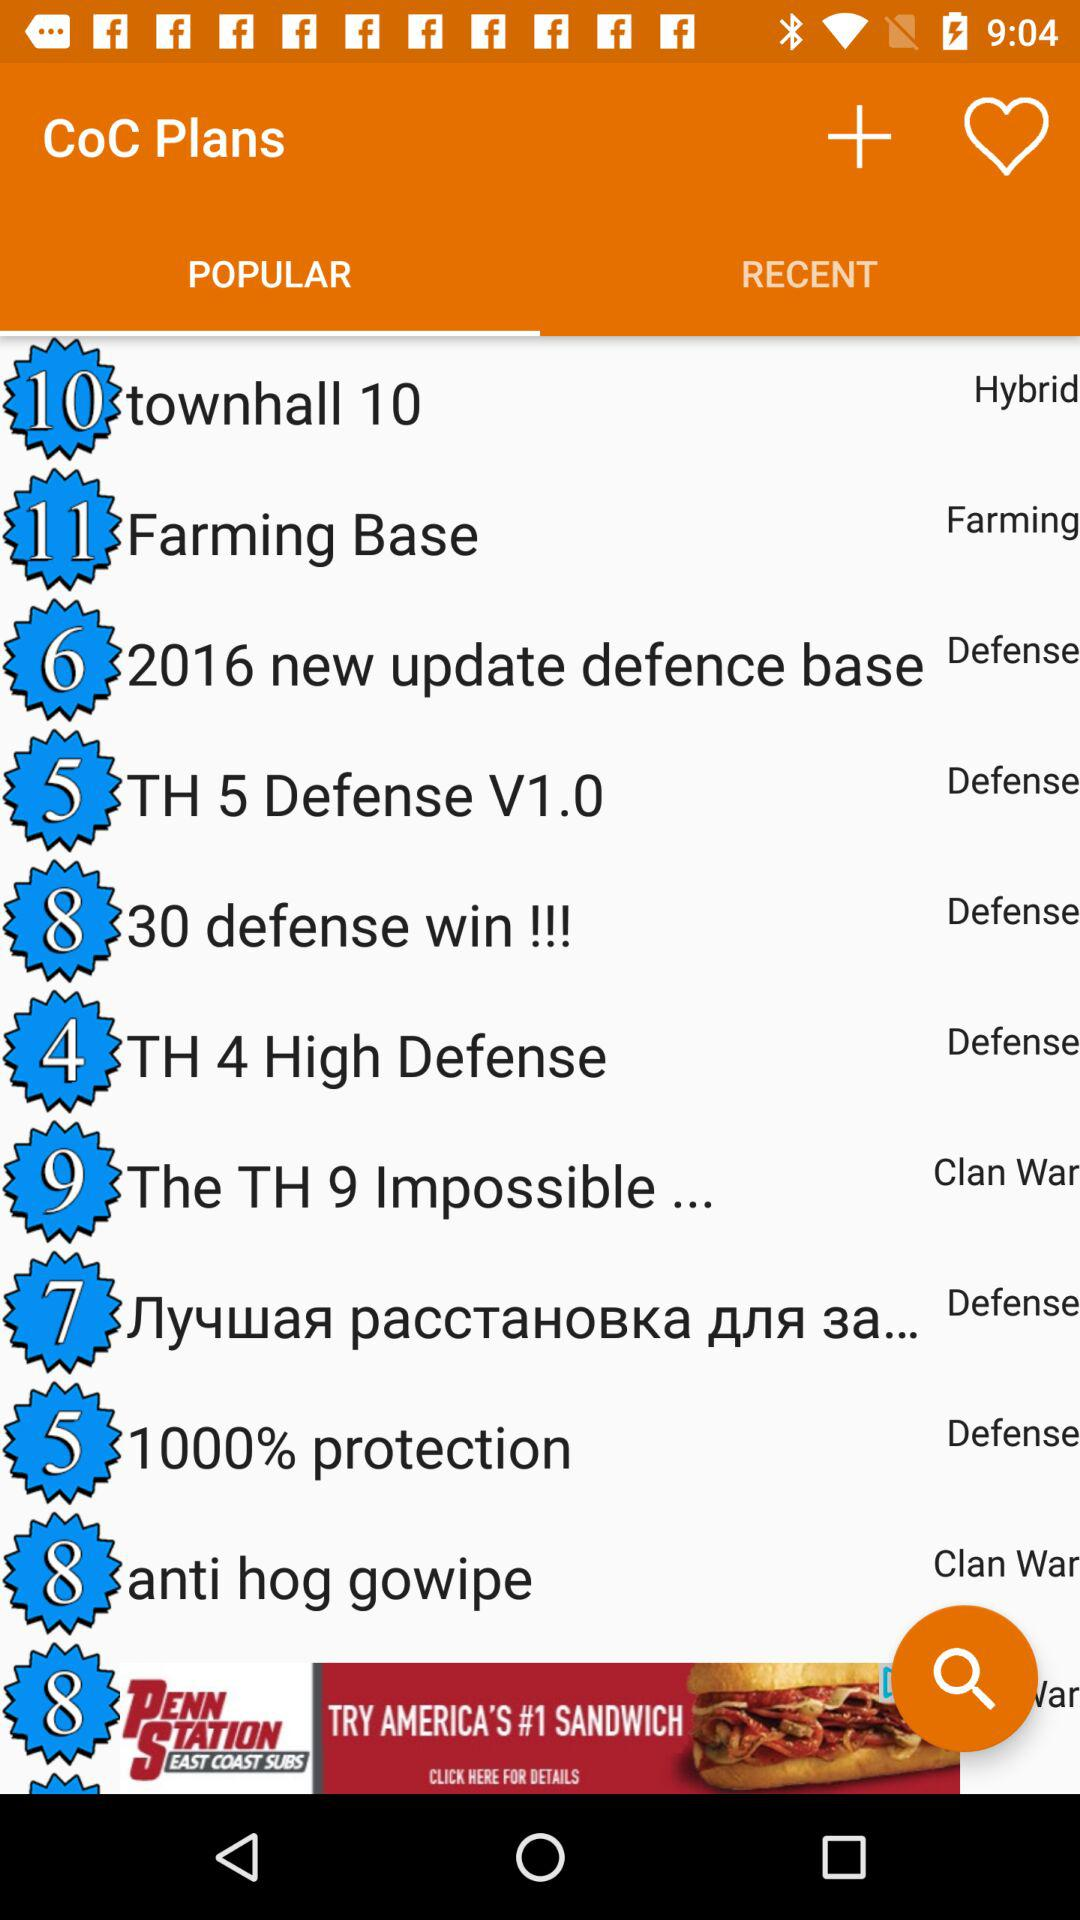Under which type of plan does "townhall 10" come? "townhall 10" comes under the "Hybrid" type of plan. 